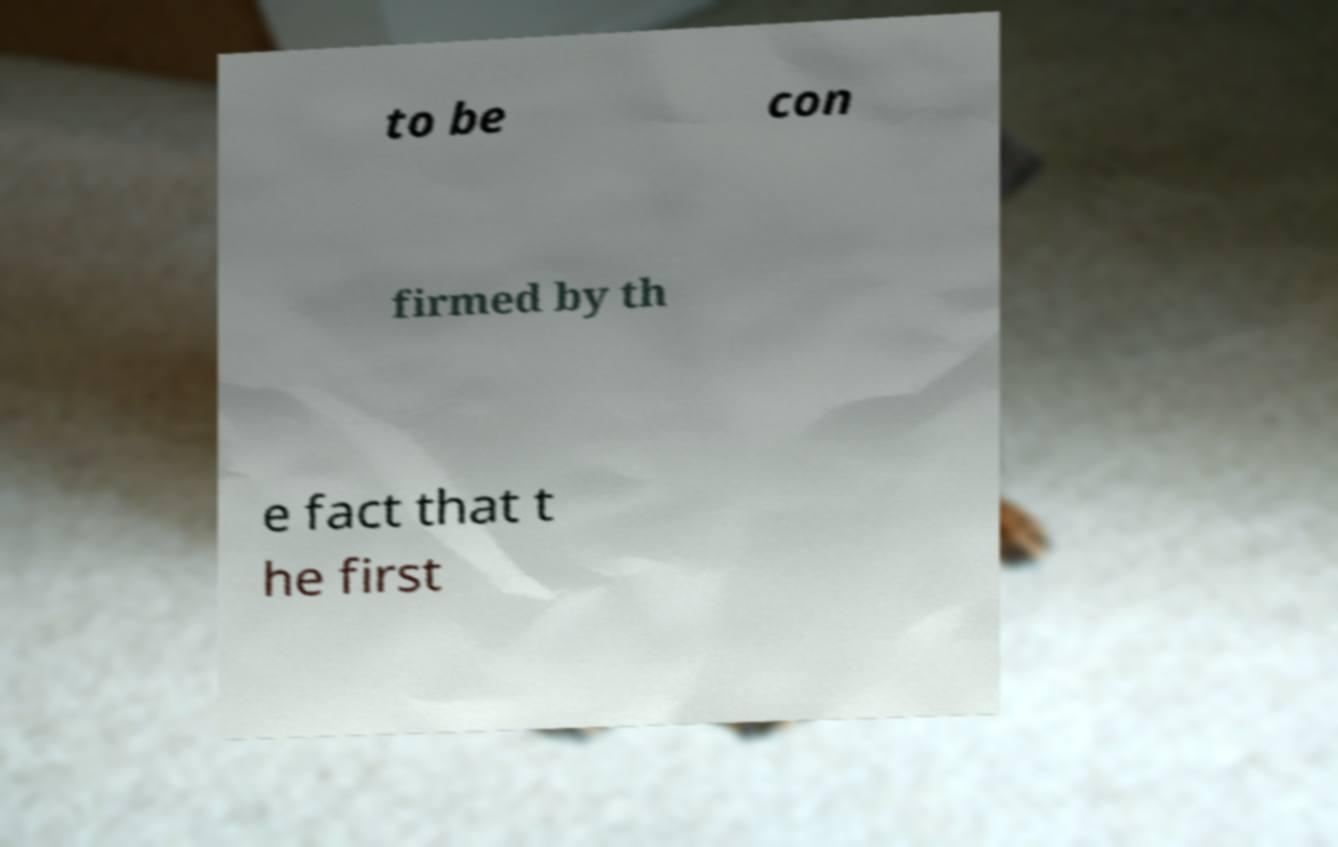Could you assist in decoding the text presented in this image and type it out clearly? to be con firmed by th e fact that t he first 